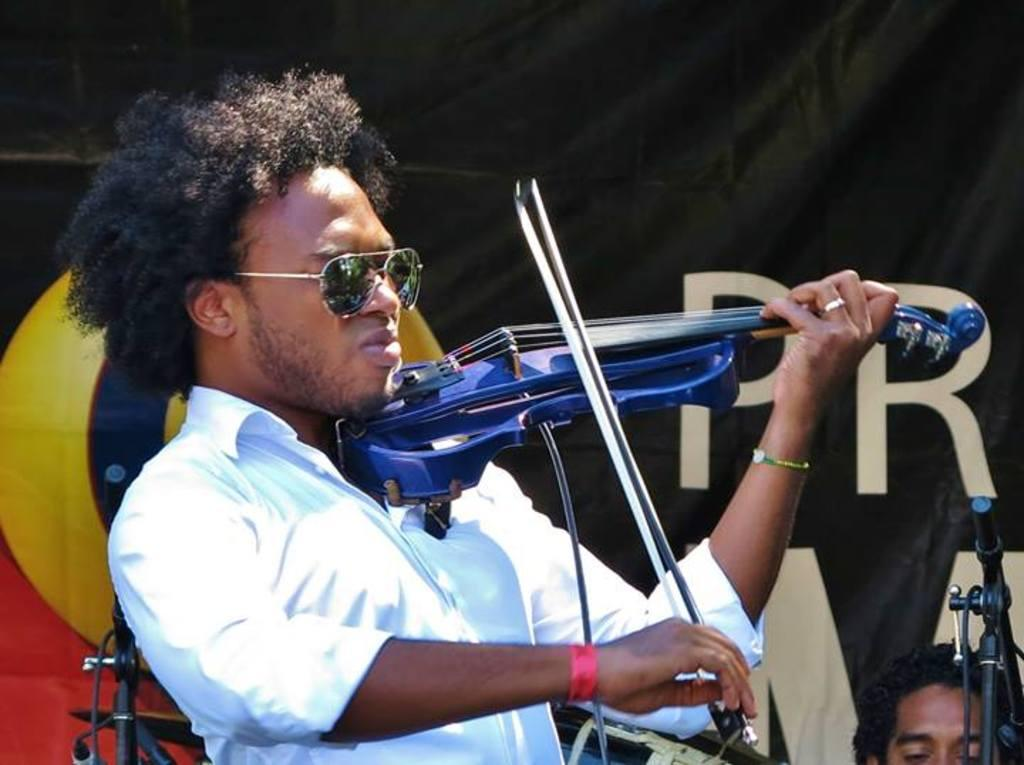What is the man in the image wearing on his upper body? The man is wearing a white shirt in the image. What is the man wearing on his face? The man is wearing goggles in the image. What instrument is the man playing in the image? The man is playing the violin with his hand in the image. What can be seen in the background of the image? There is a banner and a man in the background of the image, as well as stands. Why is the man in the image crying? There is no indication in the image that the man is crying. 